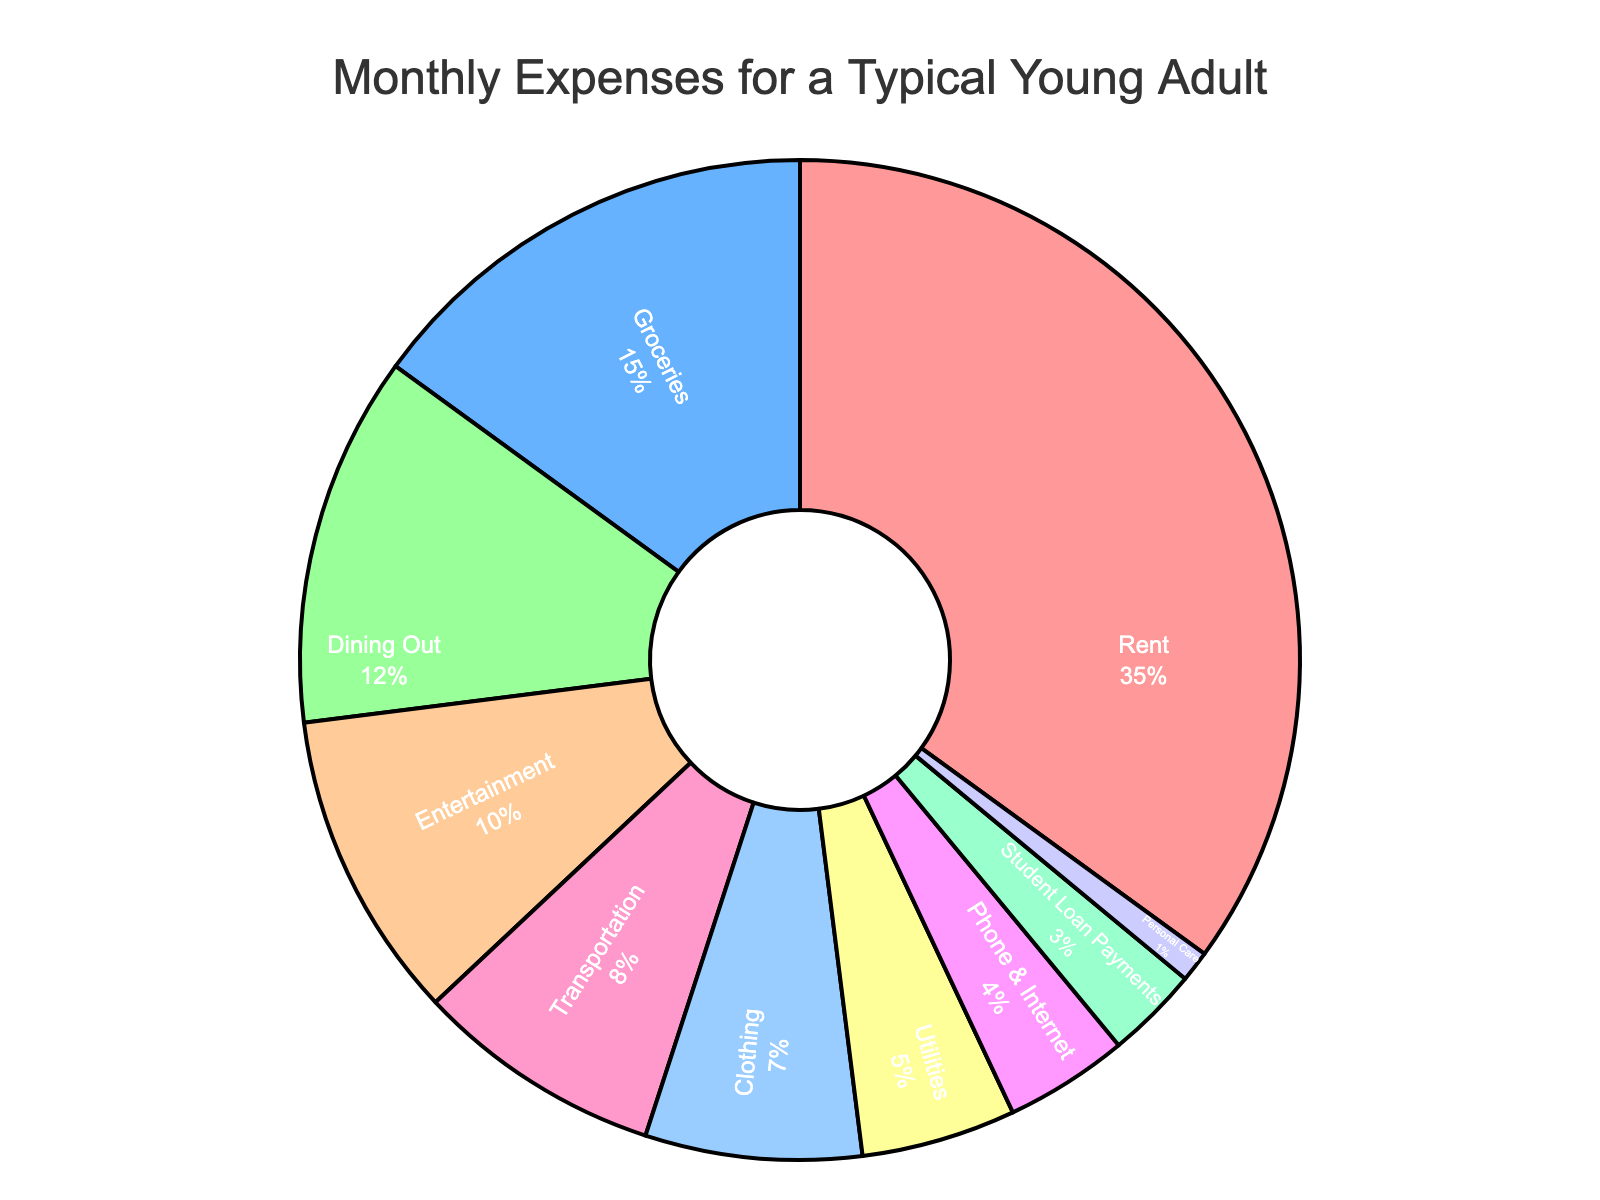What is the largest expense category? The largest percentage slice in the pie chart represents the largest expense category. The "Rent" category takes up 35% of the pie chart, which is the largest share.
Answer: Rent How many categories have a percentage lower than 10%? First, identify the slices that are less than 10%: Transportation (8%), Clothing (7%), Utilities (5%), Phone & Internet (4%), Student Loan Payments (3%), and Personal Care (1%). There are 6 such categories.
Answer: 6 What is the total percentage of essential expenses (Rent, Groceries, Utilities, Phone & Internet)? Add the percentages of Rent (35%), Groceries (15%), Utilities (5%), and Phone & Internet (4%). The sum is 35 + 15 + 5 + 4 = 59%.
Answer: 59% Which expense category has the smallest percentage? Look at the smallest slice in the pie chart to determine the category that takes up the least percentage, which is "Personal Care" at 1%.
Answer: Personal Care How much more percentage is spent on Dining Out than on Entertainment? Subtract the percentage of Entertainment (10%) from Dining Out (12%). The difference is 12% - 10% = 2%.
Answer: 2% Is the percentage spent on Groceries greater than the combined percentage of Clothing and Student Loan Payments? Compare Groceries (15%) with the sum of Clothing (7%) and Student Loan Payments (3%). The combined percentage for Clothing and Student Loan Payments is 7 + 3 = 10%, which is less than Groceries.
Answer: Yes Which category has a light blue segment, and what is its percentage? The light blue segment corresponds to the "Transportation" category. Check its percentage in the chart, which is 8%.
Answer: Transportation, 8% What is the total percentage of all expense categories with a percentage of 10% or higher? Identify and add the percentages of categories with 10% or higher: Rent (35%), Groceries (15%), Dining Out (12%), and Entertainment (10%). The sum is 35 + 15 + 12 + 10 = 72%.
Answer: 72% If the total monthly income is $3000, how much money is spent on Rent? Calculate 35% of $3000 for Rent. 0.35 * 3000 = $1050.
Answer: $1050 